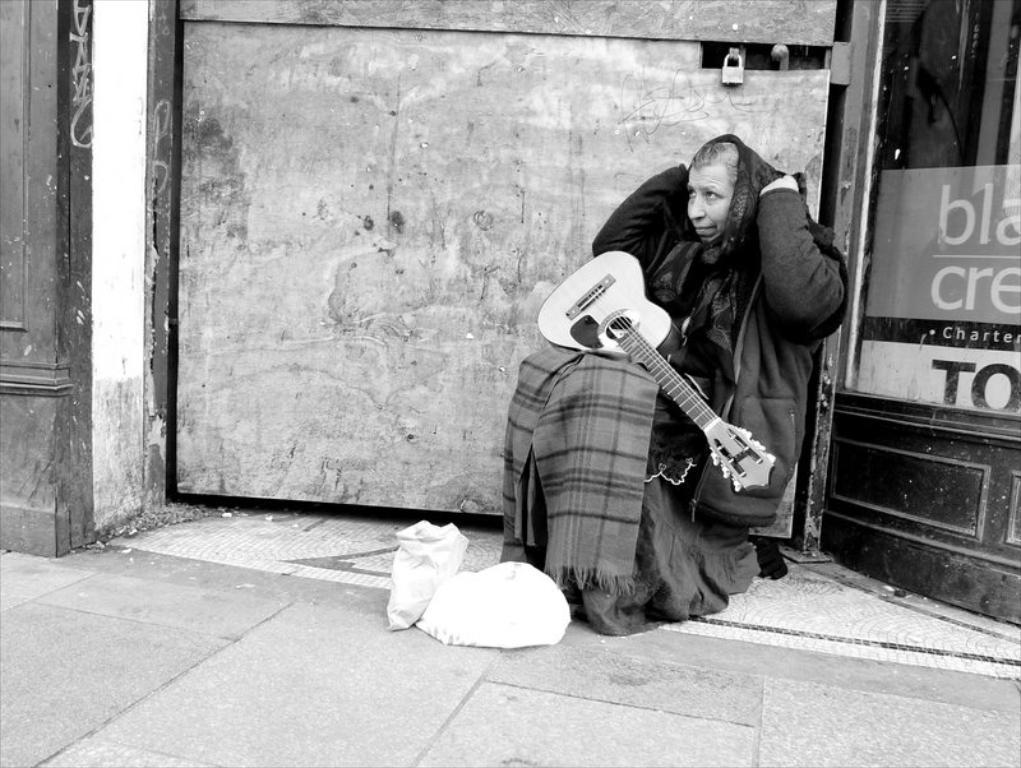Can you describe this image briefly? In the middle there is a man he is staring at something he wear a jacket ,on his lap there is a guitar in front of him there are two bags. In the background there is a glass and poster with text and a lock. 